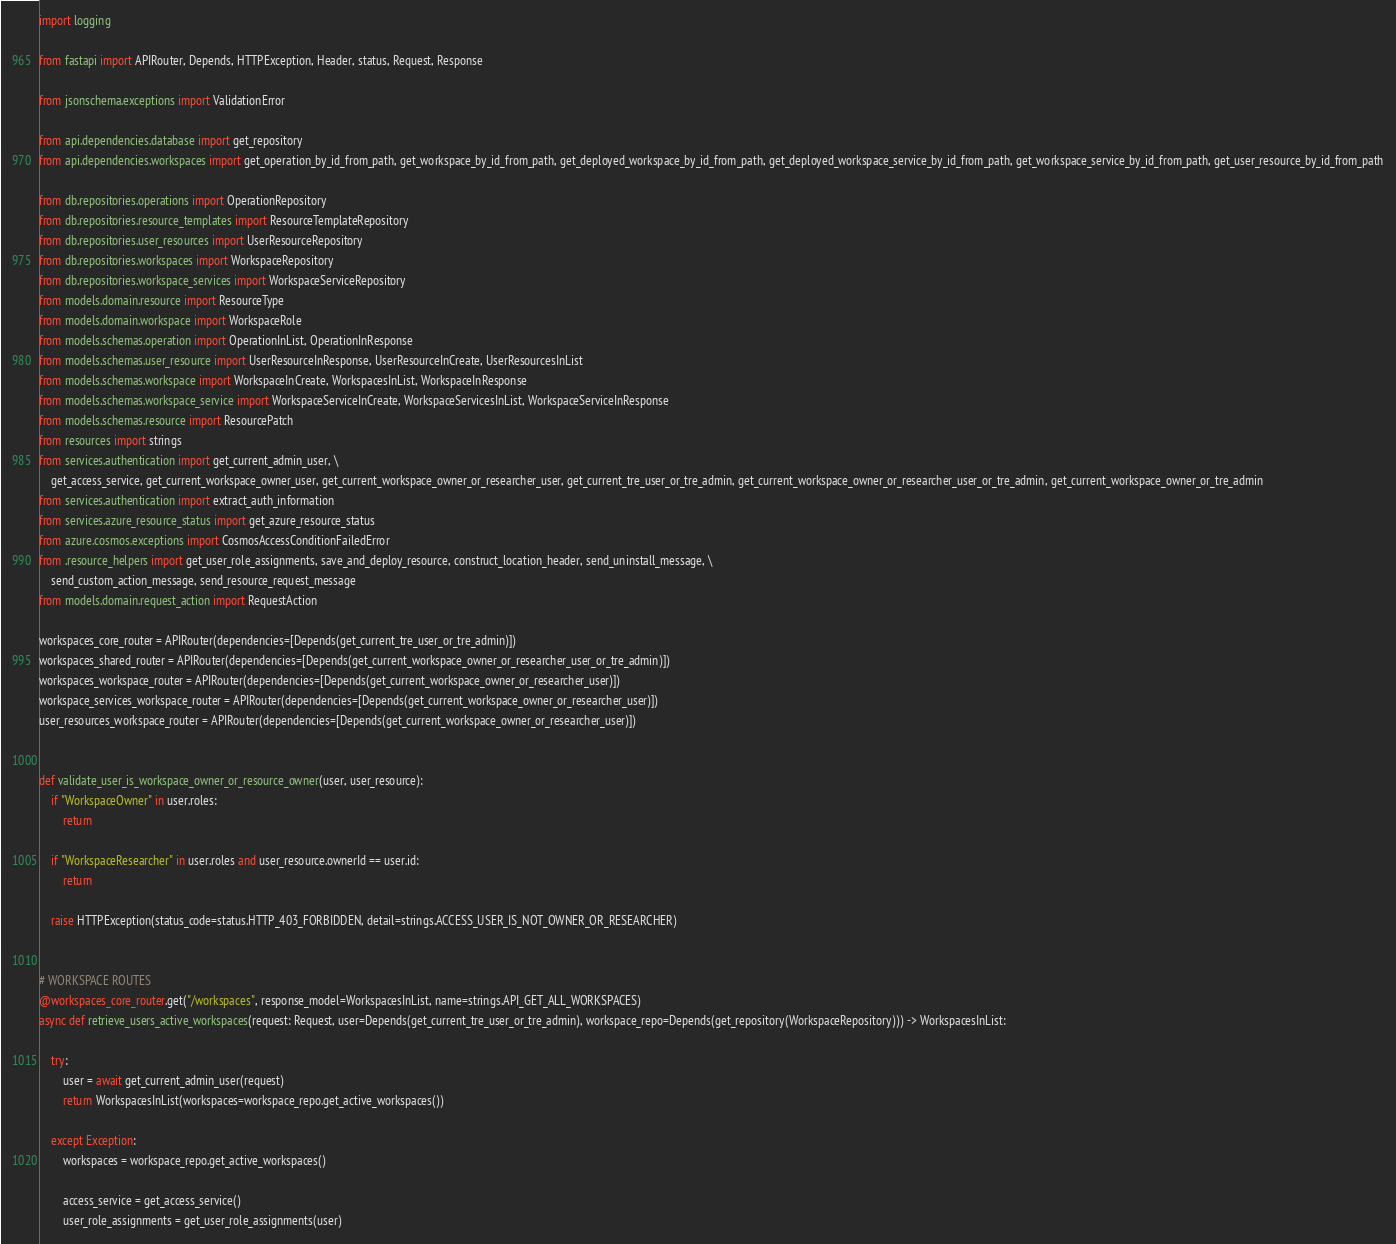<code> <loc_0><loc_0><loc_500><loc_500><_Python_>import logging

from fastapi import APIRouter, Depends, HTTPException, Header, status, Request, Response

from jsonschema.exceptions import ValidationError

from api.dependencies.database import get_repository
from api.dependencies.workspaces import get_operation_by_id_from_path, get_workspace_by_id_from_path, get_deployed_workspace_by_id_from_path, get_deployed_workspace_service_by_id_from_path, get_workspace_service_by_id_from_path, get_user_resource_by_id_from_path

from db.repositories.operations import OperationRepository
from db.repositories.resource_templates import ResourceTemplateRepository
from db.repositories.user_resources import UserResourceRepository
from db.repositories.workspaces import WorkspaceRepository
from db.repositories.workspace_services import WorkspaceServiceRepository
from models.domain.resource import ResourceType
from models.domain.workspace import WorkspaceRole
from models.schemas.operation import OperationInList, OperationInResponse
from models.schemas.user_resource import UserResourceInResponse, UserResourceInCreate, UserResourcesInList
from models.schemas.workspace import WorkspaceInCreate, WorkspacesInList, WorkspaceInResponse
from models.schemas.workspace_service import WorkspaceServiceInCreate, WorkspaceServicesInList, WorkspaceServiceInResponse
from models.schemas.resource import ResourcePatch
from resources import strings
from services.authentication import get_current_admin_user, \
    get_access_service, get_current_workspace_owner_user, get_current_workspace_owner_or_researcher_user, get_current_tre_user_or_tre_admin, get_current_workspace_owner_or_researcher_user_or_tre_admin, get_current_workspace_owner_or_tre_admin
from services.authentication import extract_auth_information
from services.azure_resource_status import get_azure_resource_status
from azure.cosmos.exceptions import CosmosAccessConditionFailedError
from .resource_helpers import get_user_role_assignments, save_and_deploy_resource, construct_location_header, send_uninstall_message, \
    send_custom_action_message, send_resource_request_message
from models.domain.request_action import RequestAction

workspaces_core_router = APIRouter(dependencies=[Depends(get_current_tre_user_or_tre_admin)])
workspaces_shared_router = APIRouter(dependencies=[Depends(get_current_workspace_owner_or_researcher_user_or_tre_admin)])
workspaces_workspace_router = APIRouter(dependencies=[Depends(get_current_workspace_owner_or_researcher_user)])
workspace_services_workspace_router = APIRouter(dependencies=[Depends(get_current_workspace_owner_or_researcher_user)])
user_resources_workspace_router = APIRouter(dependencies=[Depends(get_current_workspace_owner_or_researcher_user)])


def validate_user_is_workspace_owner_or_resource_owner(user, user_resource):
    if "WorkspaceOwner" in user.roles:
        return

    if "WorkspaceResearcher" in user.roles and user_resource.ownerId == user.id:
        return

    raise HTTPException(status_code=status.HTTP_403_FORBIDDEN, detail=strings.ACCESS_USER_IS_NOT_OWNER_OR_RESEARCHER)


# WORKSPACE ROUTES
@workspaces_core_router.get("/workspaces", response_model=WorkspacesInList, name=strings.API_GET_ALL_WORKSPACES)
async def retrieve_users_active_workspaces(request: Request, user=Depends(get_current_tre_user_or_tre_admin), workspace_repo=Depends(get_repository(WorkspaceRepository))) -> WorkspacesInList:

    try:
        user = await get_current_admin_user(request)
        return WorkspacesInList(workspaces=workspace_repo.get_active_workspaces())

    except Exception:
        workspaces = workspace_repo.get_active_workspaces()

        access_service = get_access_service()
        user_role_assignments = get_user_role_assignments(user)</code> 